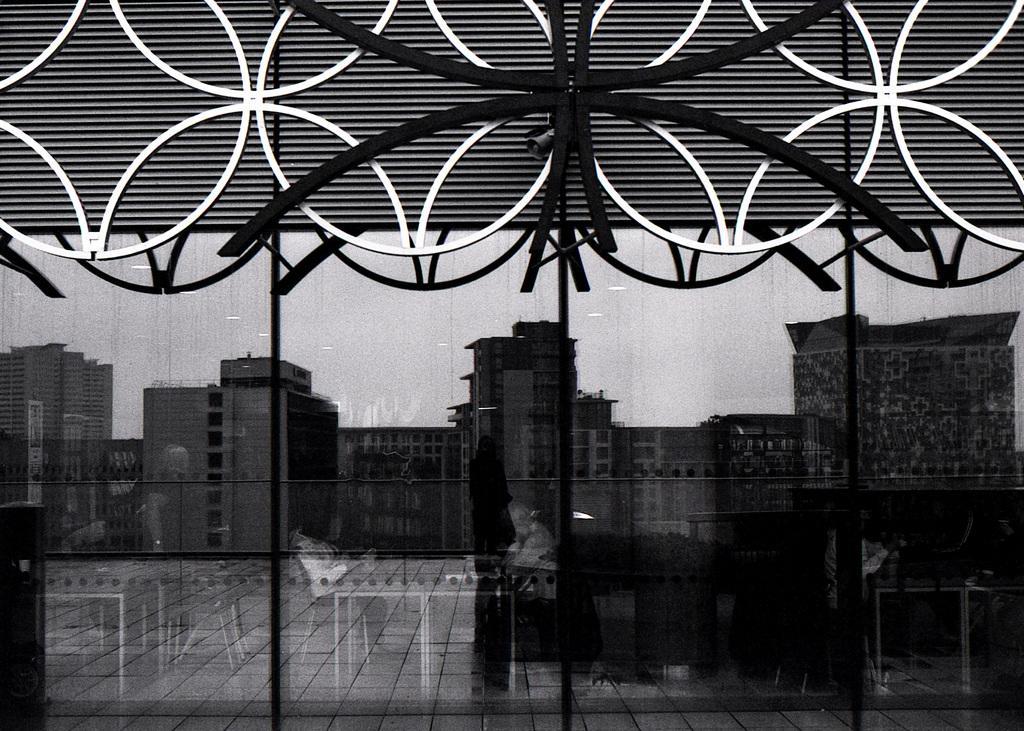Could you give a brief overview of what you see in this image? It is a black and white picture. In this image, we can see glass object. Through the glass we can see tables, chairs and floor. On the glass we can see some reflections. Here we can see a person , buildings and sky. On the right side bottom of the image, we can see few people. At the top of the image, we can see few objects. 